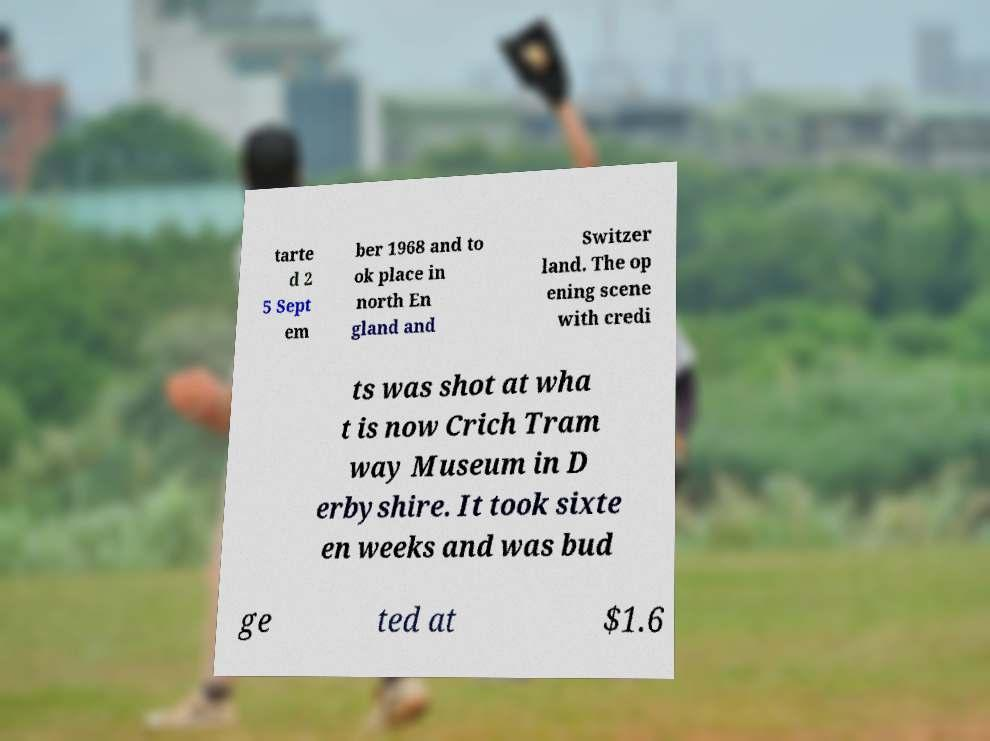Could you assist in decoding the text presented in this image and type it out clearly? tarte d 2 5 Sept em ber 1968 and to ok place in north En gland and Switzer land. The op ening scene with credi ts was shot at wha t is now Crich Tram way Museum in D erbyshire. It took sixte en weeks and was bud ge ted at $1.6 